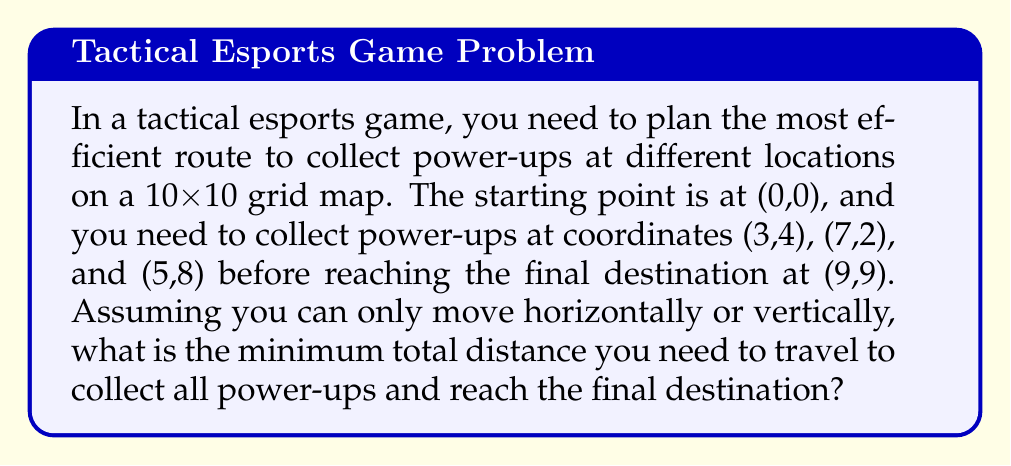Can you solve this math problem? To solve this problem, we need to find the shortest path that connects all the given points. This is similar to the Traveling Salesman Problem, but since we're working on a grid with only horizontal and vertical movements, we can use the Manhattan distance.

Let's break down the solution step-by-step:

1. Calculate the distances between each pair of points using the Manhattan distance formula:
   $d = |x_2 - x_1| + |y_2 - y_1|$

2. Start at (0,0) and find the closest power-up:
   - Distance to (3,4): $|3-0| + |4-0| = 7$
   - Distance to (7,2): $|7-0| + |2-0| = 9$
   - Distance to (5,8): $|5-0| + |8-0| = 13$
   The closest is (3,4).

3. From (3,4), calculate distances to remaining power-ups:
   - Distance to (7,2): $|7-3| + |2-4| = 6$
   - Distance to (5,8): $|5-3| + |8-4| = 6$
   Both are equidistant, so we'll choose (7,2) arbitrarily.

4. From (7,2), calculate distance to (5,8):
   - Distance: $|5-7| + |8-2| = 8$

5. Finally, calculate distance from (5,8) to the destination (9,9):
   - Distance: $|9-5| + |9-8| = 5$

6. Sum up all the distances:
   $$(0,0) \text{ to } (3,4): 7$$
   $$(3,4) \text{ to } (7,2): 6$$
   $$(7,2) \text{ to } (5,8): 8$$
   $$(5,8) \text{ to } (9,9): 5$$

   Total distance: $7 + 6 + 8 + 5 = 26$

Therefore, the minimum total distance to collect all power-ups and reach the final destination is 26 units.
Answer: 26 units 